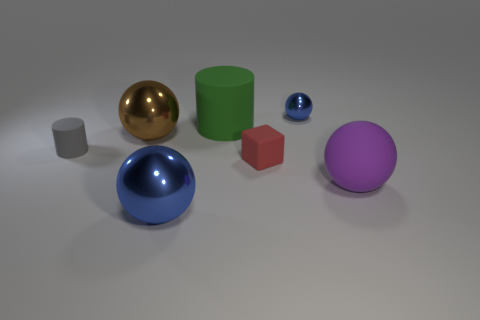Subtract 1 balls. How many balls are left? 3 Subtract all red spheres. Subtract all cyan cylinders. How many spheres are left? 4 Add 2 tiny blue things. How many objects exist? 9 Subtract all cylinders. How many objects are left? 5 Subtract 0 cyan balls. How many objects are left? 7 Subtract all large blue cubes. Subtract all blocks. How many objects are left? 6 Add 5 balls. How many balls are left? 9 Add 7 cyan shiny cylinders. How many cyan shiny cylinders exist? 7 